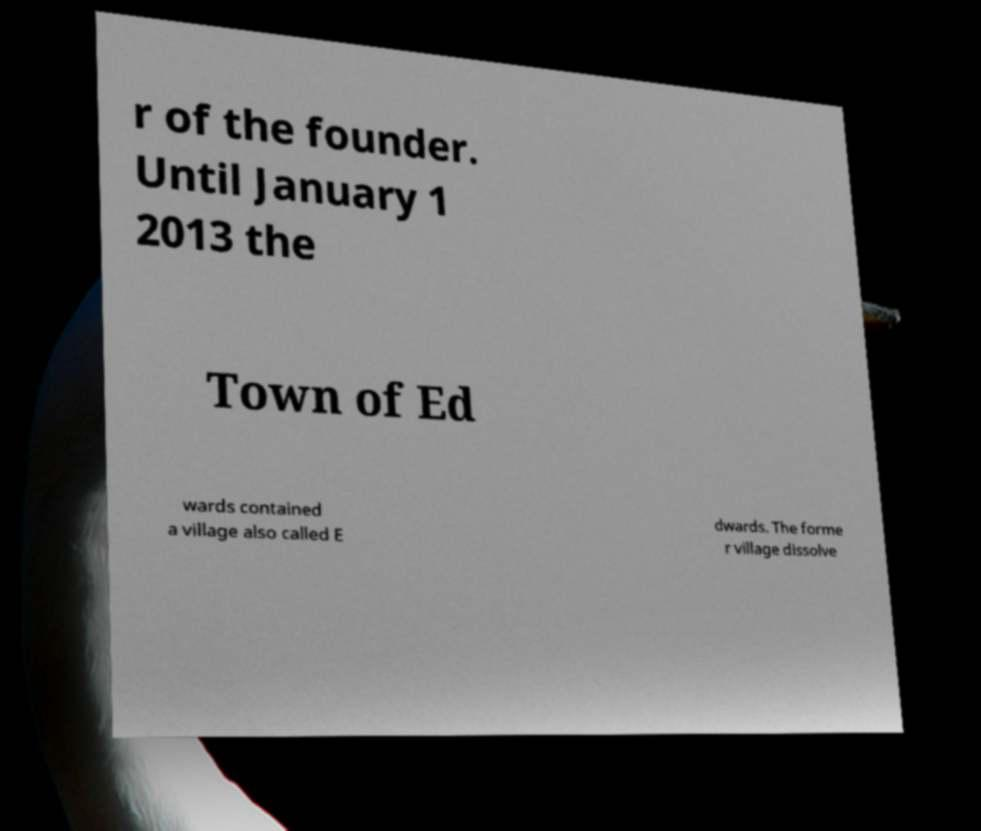Could you assist in decoding the text presented in this image and type it out clearly? r of the founder. Until January 1 2013 the Town of Ed wards contained a village also called E dwards. The forme r village dissolve 